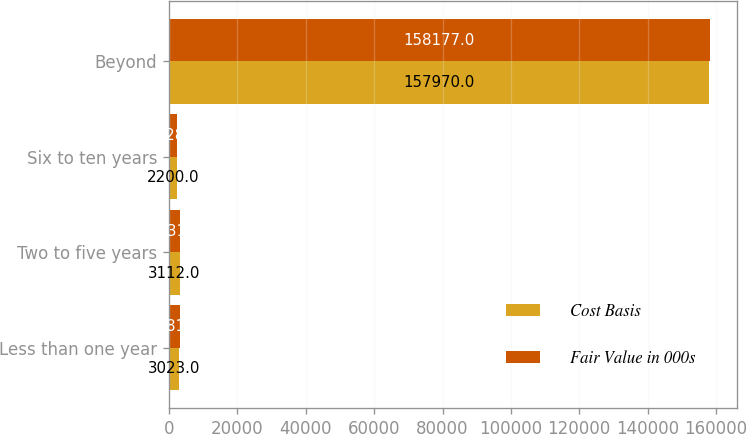<chart> <loc_0><loc_0><loc_500><loc_500><stacked_bar_chart><ecel><fcel>Less than one year<fcel>Two to five years<fcel>Six to ten years<fcel>Beyond<nl><fcel>Cost Basis<fcel>3023<fcel>3112<fcel>2200<fcel>157970<nl><fcel>Fair Value in 000s<fcel>3081<fcel>3331<fcel>2328<fcel>158177<nl></chart> 